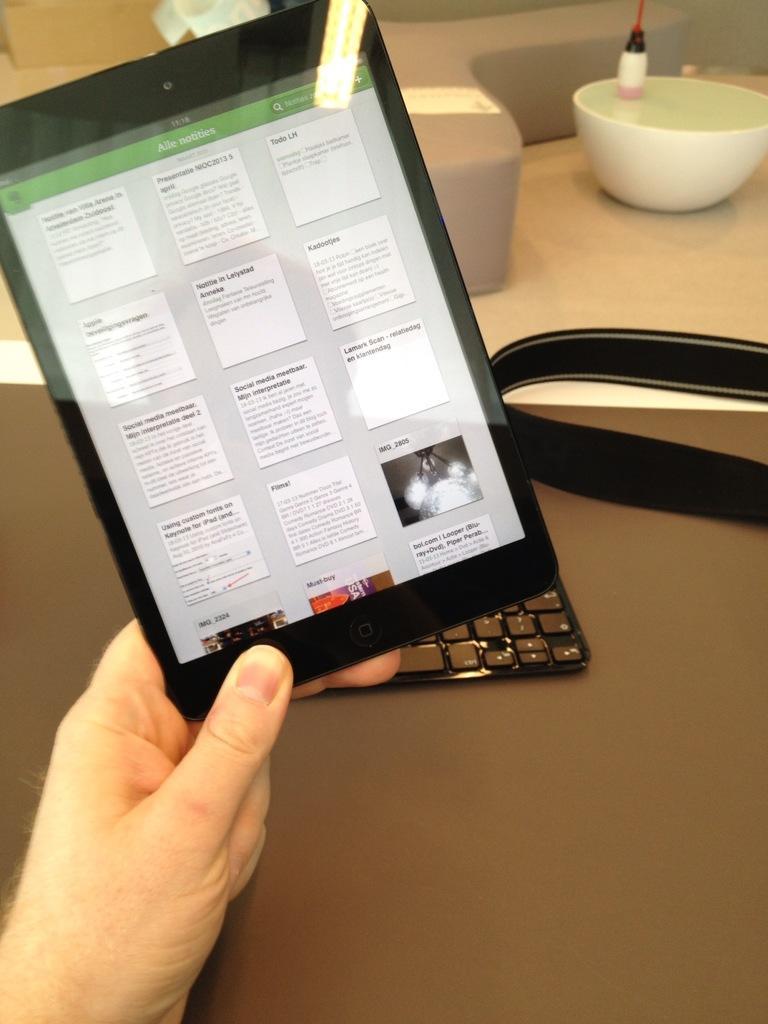Could you give a brief overview of what you see in this image? In this image we can see a person´s hand holding a tab, there is a bowl with an object, a keyboard and few other objects on the table. 